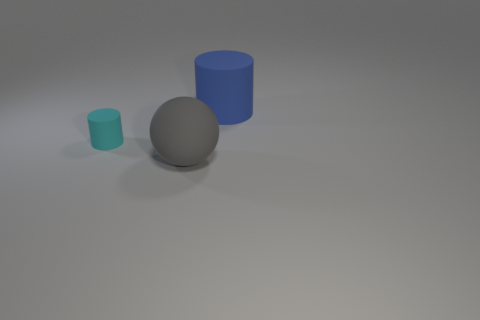Is there anything else that has the same size as the cyan thing?
Keep it short and to the point. No. How many tiny gray cylinders are there?
Offer a very short reply. 0. Are the small cylinder and the big thing that is in front of the blue rubber object made of the same material?
Offer a very short reply. Yes. What is the size of the gray ball?
Ensure brevity in your answer.  Large. What number of other things are there of the same color as the matte ball?
Your answer should be compact. 0. There is a rubber cylinder that is on the right side of the gray rubber thing; does it have the same size as the rubber sphere in front of the large blue cylinder?
Offer a terse response. Yes. The rubber thing that is on the right side of the big gray matte object is what color?
Your answer should be very brief. Blue. Are there fewer big rubber spheres behind the gray thing than large objects?
Ensure brevity in your answer.  Yes. There is another rubber thing that is the same shape as the cyan thing; what size is it?
Offer a very short reply. Large. How many things are either cylinders that are in front of the blue matte cylinder or big things that are behind the tiny object?
Offer a very short reply. 2. 